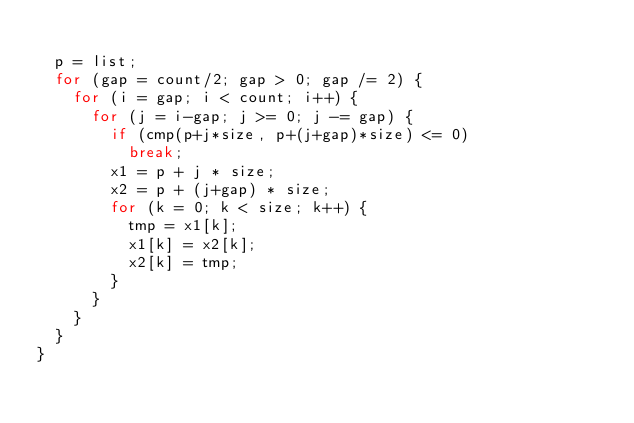Convert code to text. <code><loc_0><loc_0><loc_500><loc_500><_C_>
	p = list;
	for (gap = count/2; gap > 0; gap /= 2) {
		for (i = gap; i < count; i++) {
			for (j = i-gap; j >= 0; j -= gap) {
				if (cmp(p+j*size, p+(j+gap)*size) <= 0)
					break;
				x1 = p + j * size;
				x2 = p + (j+gap) * size;
				for (k = 0; k < size; k++) {
					tmp = x1[k];
					x1[k] = x2[k];
					x2[k] = tmp;
				}
			}
		}
	}
}
</code> 